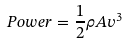Convert formula to latex. <formula><loc_0><loc_0><loc_500><loc_500>P o w e r = \frac { 1 } { 2 } \rho A v ^ { 3 }</formula> 